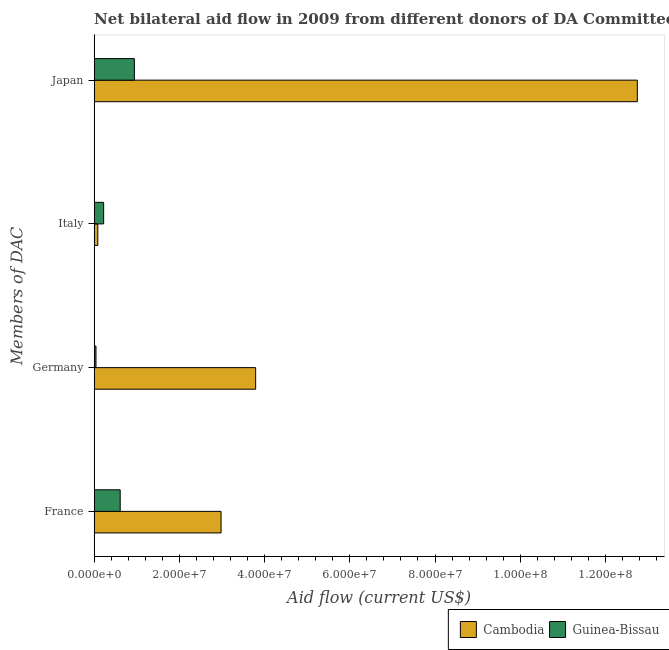How many different coloured bars are there?
Your response must be concise. 2. Are the number of bars on each tick of the Y-axis equal?
Make the answer very short. Yes. What is the label of the 4th group of bars from the top?
Provide a short and direct response. France. What is the amount of aid given by france in Cambodia?
Keep it short and to the point. 2.98e+07. Across all countries, what is the maximum amount of aid given by germany?
Ensure brevity in your answer.  3.79e+07. Across all countries, what is the minimum amount of aid given by germany?
Make the answer very short. 4.20e+05. In which country was the amount of aid given by france maximum?
Your answer should be compact. Cambodia. In which country was the amount of aid given by germany minimum?
Keep it short and to the point. Guinea-Bissau. What is the total amount of aid given by germany in the graph?
Make the answer very short. 3.83e+07. What is the difference between the amount of aid given by france in Guinea-Bissau and that in Cambodia?
Your response must be concise. -2.37e+07. What is the difference between the amount of aid given by italy in Cambodia and the amount of aid given by japan in Guinea-Bissau?
Offer a terse response. -8.58e+06. What is the average amount of aid given by germany per country?
Give a very brief answer. 1.92e+07. What is the difference between the amount of aid given by italy and amount of aid given by germany in Cambodia?
Your answer should be very brief. -3.70e+07. What is the ratio of the amount of aid given by france in Cambodia to that in Guinea-Bissau?
Ensure brevity in your answer.  4.88. Is the amount of aid given by italy in Cambodia less than that in Guinea-Bissau?
Keep it short and to the point. Yes. Is the difference between the amount of aid given by germany in Guinea-Bissau and Cambodia greater than the difference between the amount of aid given by italy in Guinea-Bissau and Cambodia?
Provide a short and direct response. No. What is the difference between the highest and the second highest amount of aid given by germany?
Provide a succinct answer. 3.75e+07. What is the difference between the highest and the lowest amount of aid given by italy?
Keep it short and to the point. 1.37e+06. In how many countries, is the amount of aid given by italy greater than the average amount of aid given by italy taken over all countries?
Ensure brevity in your answer.  1. Is it the case that in every country, the sum of the amount of aid given by france and amount of aid given by japan is greater than the sum of amount of aid given by italy and amount of aid given by germany?
Your answer should be compact. Yes. What does the 2nd bar from the top in France represents?
Keep it short and to the point. Cambodia. What does the 2nd bar from the bottom in France represents?
Your answer should be very brief. Guinea-Bissau. Is it the case that in every country, the sum of the amount of aid given by france and amount of aid given by germany is greater than the amount of aid given by italy?
Offer a terse response. Yes. Are all the bars in the graph horizontal?
Give a very brief answer. Yes. What is the difference between two consecutive major ticks on the X-axis?
Keep it short and to the point. 2.00e+07. Does the graph contain any zero values?
Offer a terse response. No. Does the graph contain grids?
Offer a very short reply. No. How many legend labels are there?
Ensure brevity in your answer.  2. How are the legend labels stacked?
Ensure brevity in your answer.  Horizontal. What is the title of the graph?
Your response must be concise. Net bilateral aid flow in 2009 from different donors of DA Committee. Does "Malaysia" appear as one of the legend labels in the graph?
Ensure brevity in your answer.  No. What is the label or title of the X-axis?
Make the answer very short. Aid flow (current US$). What is the label or title of the Y-axis?
Provide a succinct answer. Members of DAC. What is the Aid flow (current US$) of Cambodia in France?
Provide a short and direct response. 2.98e+07. What is the Aid flow (current US$) in Guinea-Bissau in France?
Offer a very short reply. 6.10e+06. What is the Aid flow (current US$) in Cambodia in Germany?
Give a very brief answer. 3.79e+07. What is the Aid flow (current US$) of Guinea-Bissau in Germany?
Provide a succinct answer. 4.20e+05. What is the Aid flow (current US$) of Cambodia in Italy?
Your answer should be very brief. 8.50e+05. What is the Aid flow (current US$) in Guinea-Bissau in Italy?
Ensure brevity in your answer.  2.22e+06. What is the Aid flow (current US$) of Cambodia in Japan?
Ensure brevity in your answer.  1.27e+08. What is the Aid flow (current US$) of Guinea-Bissau in Japan?
Keep it short and to the point. 9.43e+06. Across all Members of DAC, what is the maximum Aid flow (current US$) of Cambodia?
Your response must be concise. 1.27e+08. Across all Members of DAC, what is the maximum Aid flow (current US$) of Guinea-Bissau?
Provide a succinct answer. 9.43e+06. Across all Members of DAC, what is the minimum Aid flow (current US$) in Cambodia?
Make the answer very short. 8.50e+05. What is the total Aid flow (current US$) in Cambodia in the graph?
Provide a short and direct response. 1.96e+08. What is the total Aid flow (current US$) in Guinea-Bissau in the graph?
Provide a succinct answer. 1.82e+07. What is the difference between the Aid flow (current US$) in Cambodia in France and that in Germany?
Provide a succinct answer. -8.12e+06. What is the difference between the Aid flow (current US$) of Guinea-Bissau in France and that in Germany?
Provide a succinct answer. 5.68e+06. What is the difference between the Aid flow (current US$) in Cambodia in France and that in Italy?
Give a very brief answer. 2.89e+07. What is the difference between the Aid flow (current US$) of Guinea-Bissau in France and that in Italy?
Give a very brief answer. 3.88e+06. What is the difference between the Aid flow (current US$) of Cambodia in France and that in Japan?
Give a very brief answer. -9.77e+07. What is the difference between the Aid flow (current US$) of Guinea-Bissau in France and that in Japan?
Your answer should be compact. -3.33e+06. What is the difference between the Aid flow (current US$) in Cambodia in Germany and that in Italy?
Give a very brief answer. 3.70e+07. What is the difference between the Aid flow (current US$) of Guinea-Bissau in Germany and that in Italy?
Offer a very short reply. -1.80e+06. What is the difference between the Aid flow (current US$) in Cambodia in Germany and that in Japan?
Provide a succinct answer. -8.96e+07. What is the difference between the Aid flow (current US$) of Guinea-Bissau in Germany and that in Japan?
Your answer should be compact. -9.01e+06. What is the difference between the Aid flow (current US$) of Cambodia in Italy and that in Japan?
Keep it short and to the point. -1.27e+08. What is the difference between the Aid flow (current US$) in Guinea-Bissau in Italy and that in Japan?
Offer a terse response. -7.21e+06. What is the difference between the Aid flow (current US$) of Cambodia in France and the Aid flow (current US$) of Guinea-Bissau in Germany?
Offer a very short reply. 2.94e+07. What is the difference between the Aid flow (current US$) in Cambodia in France and the Aid flow (current US$) in Guinea-Bissau in Italy?
Make the answer very short. 2.76e+07. What is the difference between the Aid flow (current US$) of Cambodia in France and the Aid flow (current US$) of Guinea-Bissau in Japan?
Your answer should be compact. 2.04e+07. What is the difference between the Aid flow (current US$) of Cambodia in Germany and the Aid flow (current US$) of Guinea-Bissau in Italy?
Give a very brief answer. 3.57e+07. What is the difference between the Aid flow (current US$) in Cambodia in Germany and the Aid flow (current US$) in Guinea-Bissau in Japan?
Provide a short and direct response. 2.85e+07. What is the difference between the Aid flow (current US$) of Cambodia in Italy and the Aid flow (current US$) of Guinea-Bissau in Japan?
Your answer should be very brief. -8.58e+06. What is the average Aid flow (current US$) of Cambodia per Members of DAC?
Offer a terse response. 4.90e+07. What is the average Aid flow (current US$) of Guinea-Bissau per Members of DAC?
Your response must be concise. 4.54e+06. What is the difference between the Aid flow (current US$) of Cambodia and Aid flow (current US$) of Guinea-Bissau in France?
Make the answer very short. 2.37e+07. What is the difference between the Aid flow (current US$) of Cambodia and Aid flow (current US$) of Guinea-Bissau in Germany?
Your answer should be very brief. 3.75e+07. What is the difference between the Aid flow (current US$) of Cambodia and Aid flow (current US$) of Guinea-Bissau in Italy?
Offer a terse response. -1.37e+06. What is the difference between the Aid flow (current US$) in Cambodia and Aid flow (current US$) in Guinea-Bissau in Japan?
Offer a terse response. 1.18e+08. What is the ratio of the Aid flow (current US$) in Cambodia in France to that in Germany?
Give a very brief answer. 0.79. What is the ratio of the Aid flow (current US$) of Guinea-Bissau in France to that in Germany?
Ensure brevity in your answer.  14.52. What is the ratio of the Aid flow (current US$) in Cambodia in France to that in Italy?
Your response must be concise. 35.04. What is the ratio of the Aid flow (current US$) of Guinea-Bissau in France to that in Italy?
Give a very brief answer. 2.75. What is the ratio of the Aid flow (current US$) of Cambodia in France to that in Japan?
Your answer should be very brief. 0.23. What is the ratio of the Aid flow (current US$) of Guinea-Bissau in France to that in Japan?
Provide a short and direct response. 0.65. What is the ratio of the Aid flow (current US$) of Cambodia in Germany to that in Italy?
Your answer should be compact. 44.59. What is the ratio of the Aid flow (current US$) in Guinea-Bissau in Germany to that in Italy?
Your response must be concise. 0.19. What is the ratio of the Aid flow (current US$) in Cambodia in Germany to that in Japan?
Provide a short and direct response. 0.3. What is the ratio of the Aid flow (current US$) in Guinea-Bissau in Germany to that in Japan?
Your answer should be compact. 0.04. What is the ratio of the Aid flow (current US$) in Cambodia in Italy to that in Japan?
Provide a short and direct response. 0.01. What is the ratio of the Aid flow (current US$) of Guinea-Bissau in Italy to that in Japan?
Ensure brevity in your answer.  0.24. What is the difference between the highest and the second highest Aid flow (current US$) of Cambodia?
Make the answer very short. 8.96e+07. What is the difference between the highest and the second highest Aid flow (current US$) in Guinea-Bissau?
Ensure brevity in your answer.  3.33e+06. What is the difference between the highest and the lowest Aid flow (current US$) in Cambodia?
Offer a terse response. 1.27e+08. What is the difference between the highest and the lowest Aid flow (current US$) in Guinea-Bissau?
Give a very brief answer. 9.01e+06. 